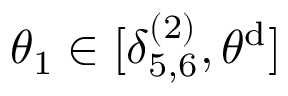<formula> <loc_0><loc_0><loc_500><loc_500>\theta _ { 1 } \in [ \delta _ { 5 , 6 } ^ { ( 2 ) } , \theta ^ { d } ]</formula> 